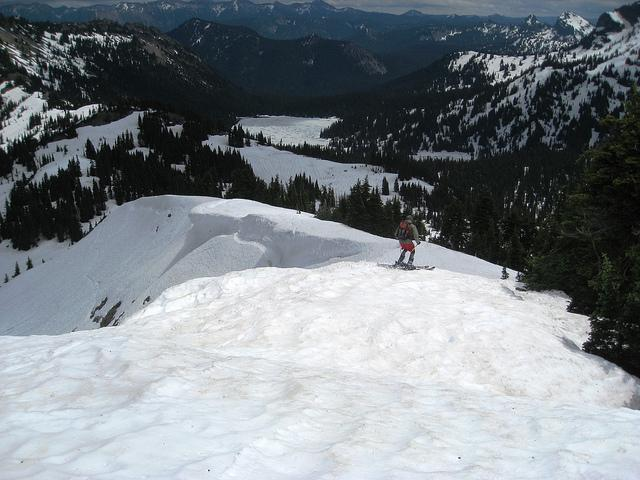From where did this person directly come? up high 